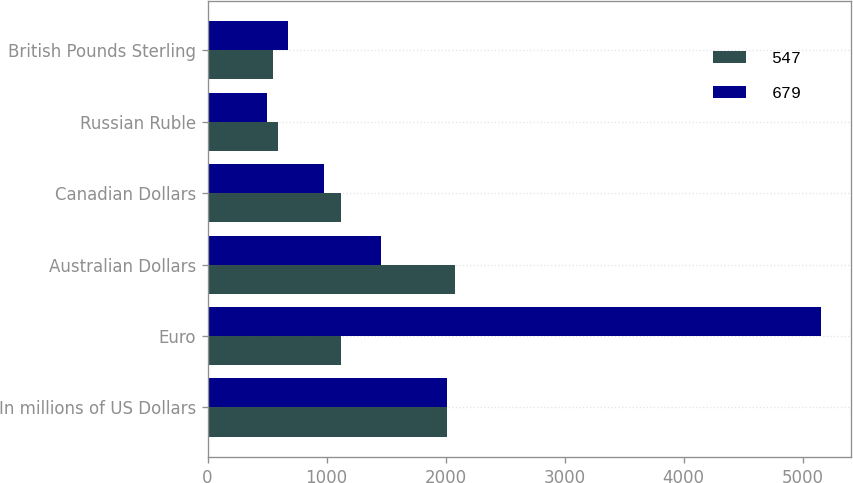<chart> <loc_0><loc_0><loc_500><loc_500><stacked_bar_chart><ecel><fcel>In millions of US Dollars<fcel>Euro<fcel>Australian Dollars<fcel>Canadian Dollars<fcel>Russian Ruble<fcel>British Pounds Sterling<nl><fcel>547<fcel>2010<fcel>1123<fcel>2075<fcel>1123<fcel>589<fcel>547<nl><fcel>679<fcel>2009<fcel>5151<fcel>1460<fcel>981<fcel>501<fcel>679<nl></chart> 